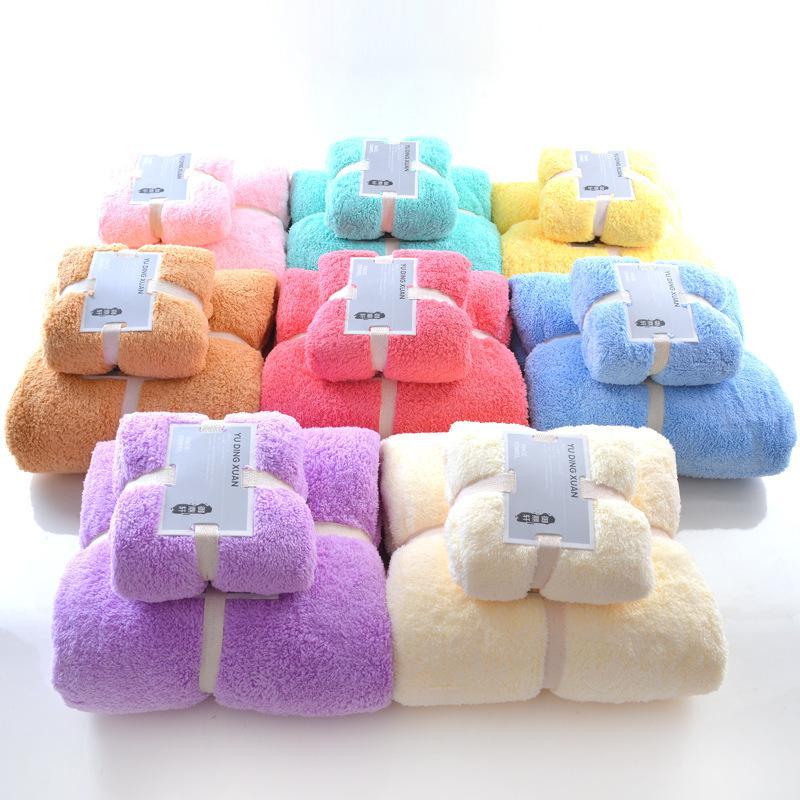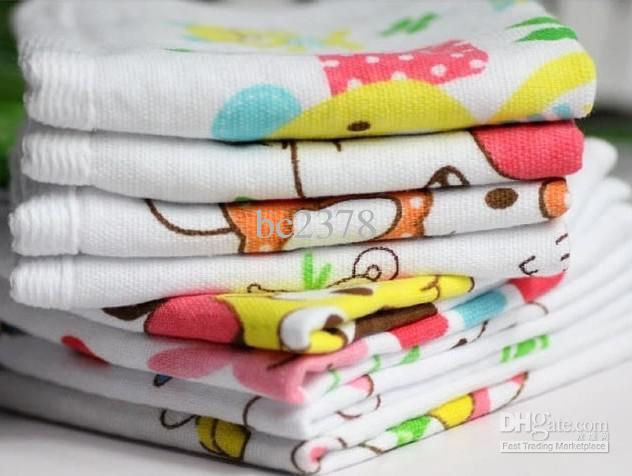The first image is the image on the left, the second image is the image on the right. Assess this claim about the two images: "One image features only solid-colored towels in varying colors.". Correct or not? Answer yes or no. Yes. 